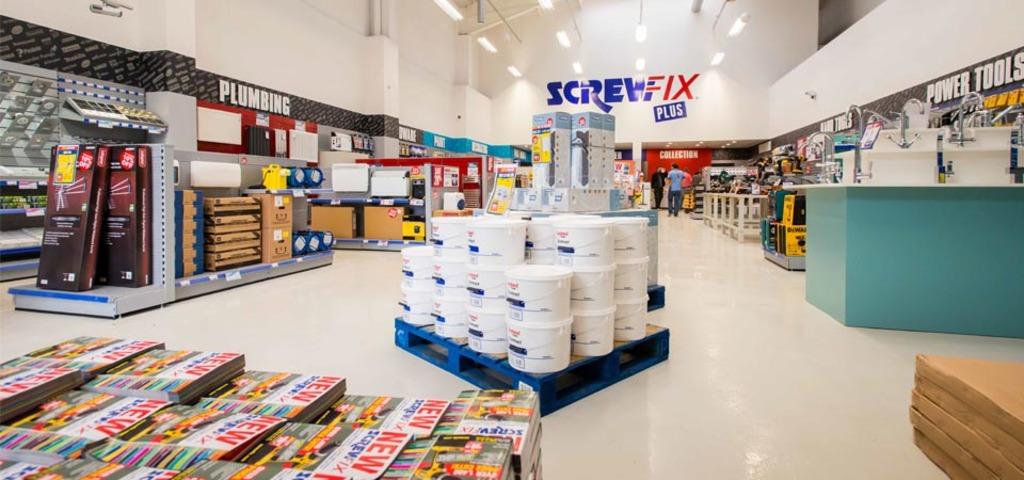What merchandise section is displayed on the left?
Ensure brevity in your answer.  Plumbing. 